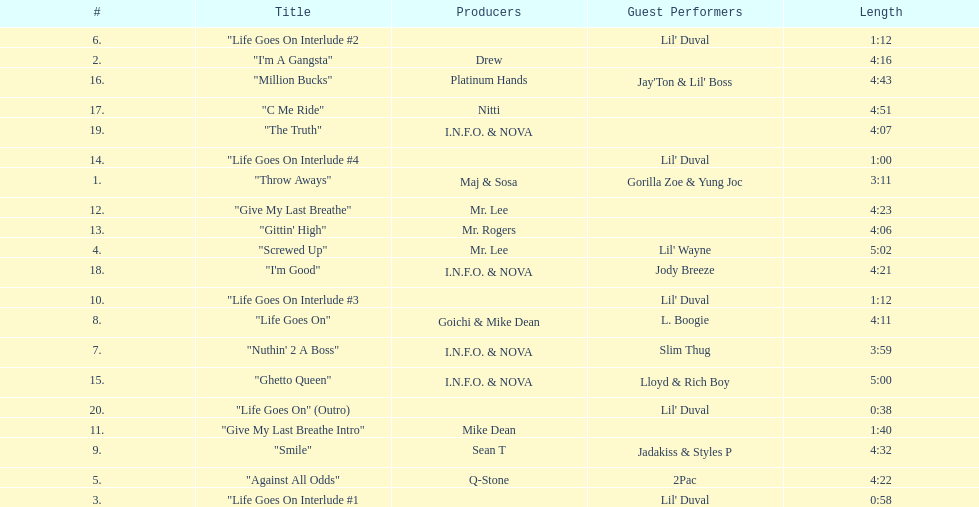Can you tell me the length of track 11? 1:40. 